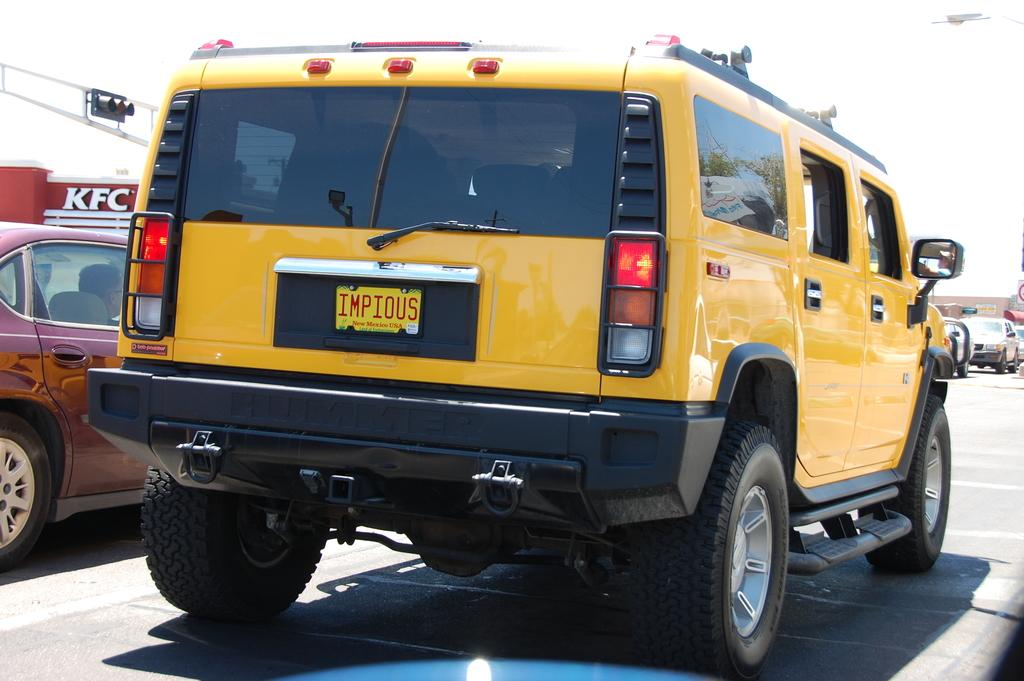What types of objects can be seen in the image? There are vehicles in the image. What else is present in the image besides the vehicles? There is a board with text in the image. What type of engine is visible in the image? There is no engine visible in the image; it only shows vehicles and a board with text. Can you tell me how many friends are present in the image? There is no reference to friends or any people in the image, so it cannot be determined from the image. 